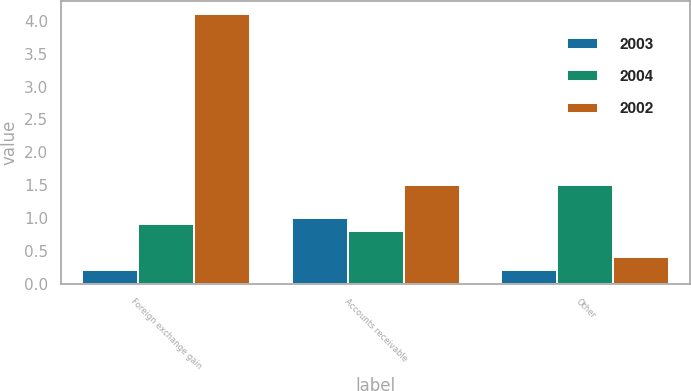<chart> <loc_0><loc_0><loc_500><loc_500><stacked_bar_chart><ecel><fcel>Foreign exchange gain<fcel>Accounts receivable<fcel>Other<nl><fcel>2003<fcel>0.2<fcel>1<fcel>0.2<nl><fcel>2004<fcel>0.9<fcel>0.8<fcel>1.5<nl><fcel>2002<fcel>4.1<fcel>1.5<fcel>0.4<nl></chart> 